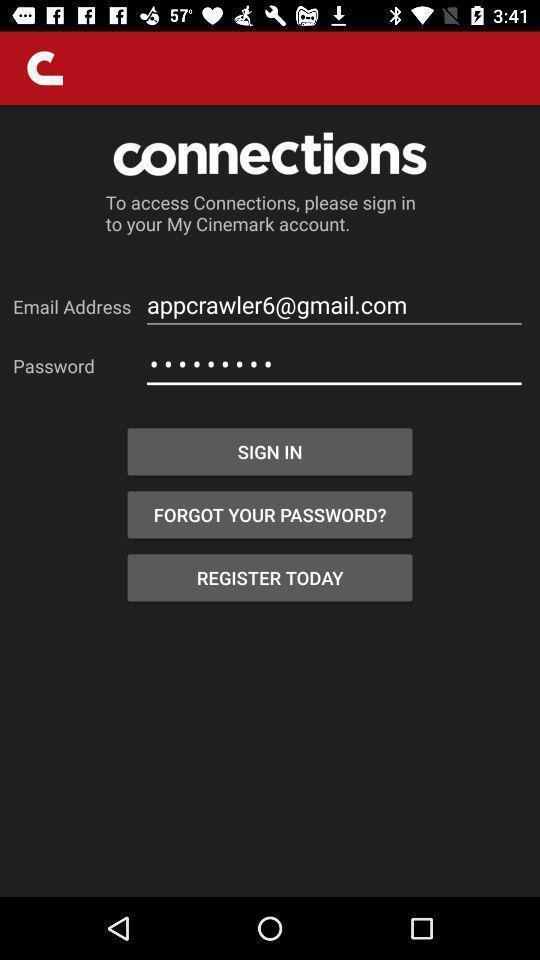Summarize the main components in this picture. Sign in page to enter details and to create account. 